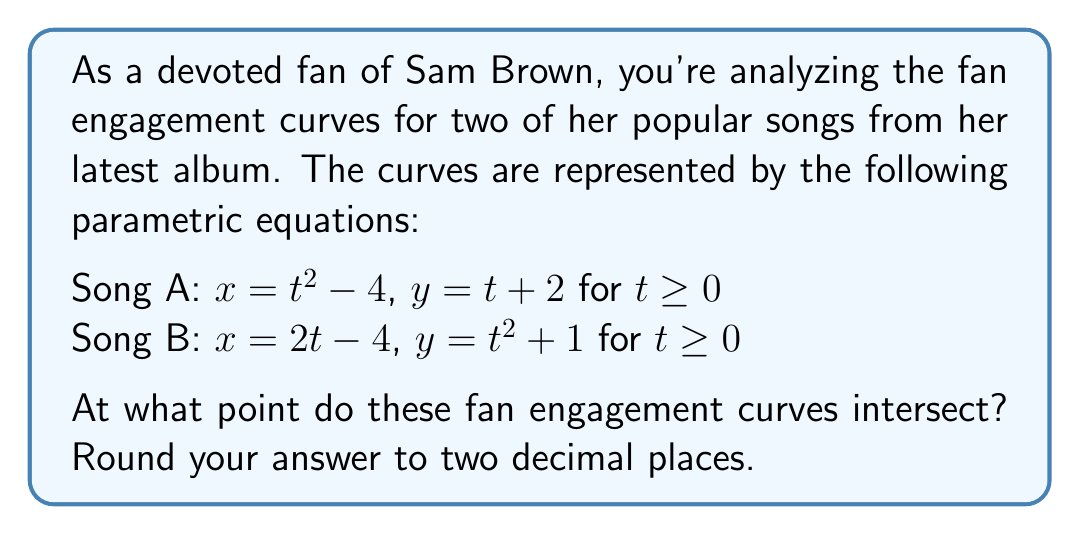Can you answer this question? To find the intersection point of these two parametric curves, we need to equate their x and y components:

1) Equate x-components:
   $t^2 - 4 = 2t - 4$
   $t^2 - 2t = 0$
   $t(t - 2) = 0$
   $t = 0$ or $t = 2$

   Since $t \geq 0$ for both curves, we'll use $t = 2$ for further calculations.

2) Verify using y-components:
   For Song A: $y = t + 2 = 2 + 2 = 4$
   For Song B: $y = t^2 + 1 = 2^2 + 1 = 5$

   The y-values don't match, so $t = 2$ is not the solution.

3) Let's solve by substituting $x = t^2 - 4$ into Song B's equation:
   $t^2 - 4 = 2t - 4$
   $t^2 - 2t = 0$
   $t(t - 2) = 0$
   $t = 0$ or $t = 2$

4) Now, let's find the corresponding $t$ value for Song B:
   $2t - 4 = t^2 - 4$
   $2t = t^2$
   $t^2 - 2t = 0$
   $t(t - 2) = 0$
   $t = 0$ or $t = 2$

5) We find that $t = 2$ satisfies both equations. Let's calculate the intersection point:

   For Song A (using $t = 2$):
   $x = 2^2 - 4 = 0$
   $y = 2 + 2 = 4$

   For Song B (using $t = 2$):
   $x = 2(2) - 4 = 0$
   $y = 2^2 + 1 = 5$

6) The intersection point is $(0, 4)$.
Answer: The fan engagement curves for Song A and Song B intersect at the point $(0.00, 4.00)$. 